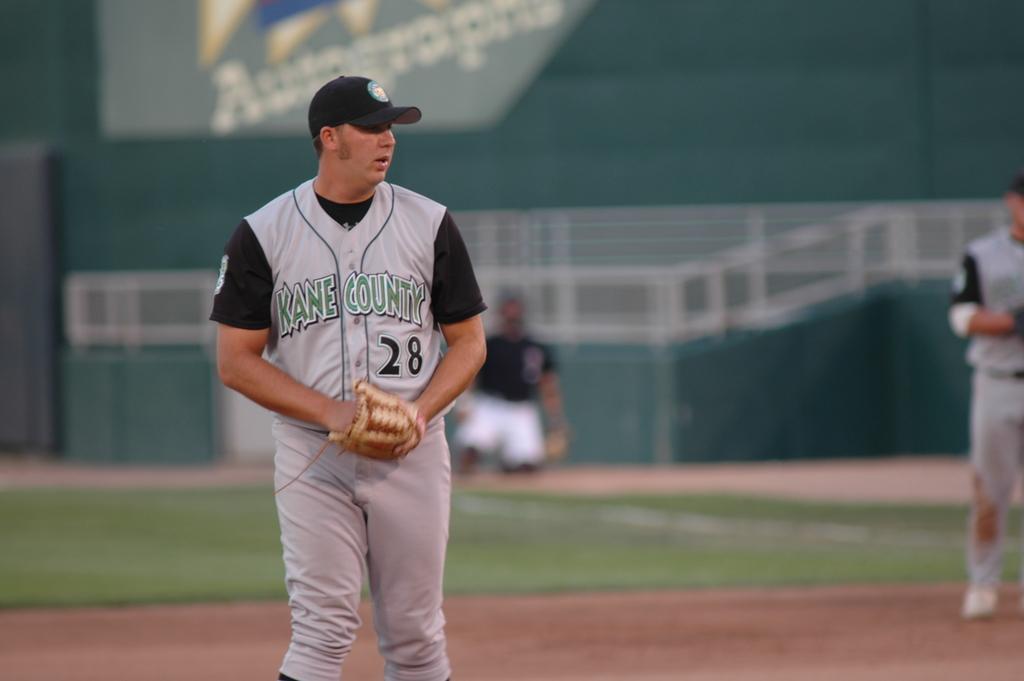What is his number?
Give a very brief answer. 28. 